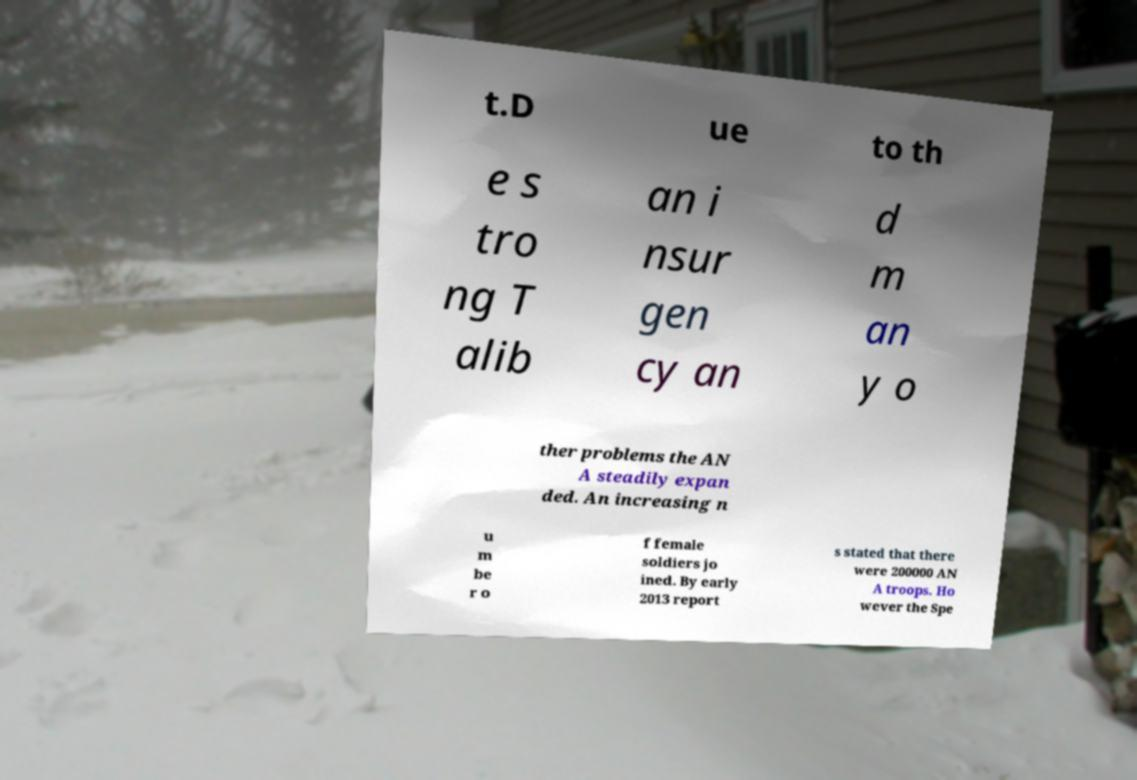Can you accurately transcribe the text from the provided image for me? t.D ue to th e s tro ng T alib an i nsur gen cy an d m an y o ther problems the AN A steadily expan ded. An increasing n u m be r o f female soldiers jo ined. By early 2013 report s stated that there were 200000 AN A troops. Ho wever the Spe 